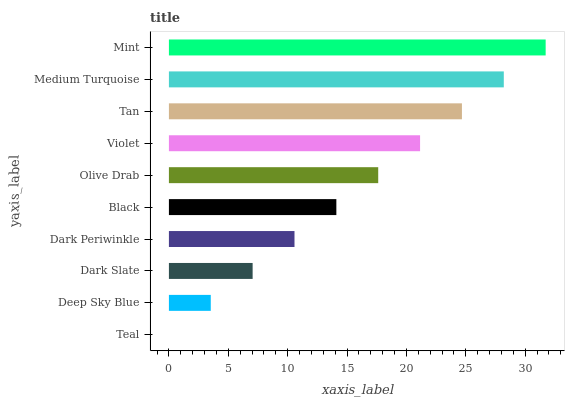Is Teal the minimum?
Answer yes or no. Yes. Is Mint the maximum?
Answer yes or no. Yes. Is Deep Sky Blue the minimum?
Answer yes or no. No. Is Deep Sky Blue the maximum?
Answer yes or no. No. Is Deep Sky Blue greater than Teal?
Answer yes or no. Yes. Is Teal less than Deep Sky Blue?
Answer yes or no. Yes. Is Teal greater than Deep Sky Blue?
Answer yes or no. No. Is Deep Sky Blue less than Teal?
Answer yes or no. No. Is Olive Drab the high median?
Answer yes or no. Yes. Is Black the low median?
Answer yes or no. Yes. Is Black the high median?
Answer yes or no. No. Is Deep Sky Blue the low median?
Answer yes or no. No. 